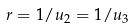<formula> <loc_0><loc_0><loc_500><loc_500>r = 1 / u _ { 2 } = 1 / u _ { 3 }</formula> 